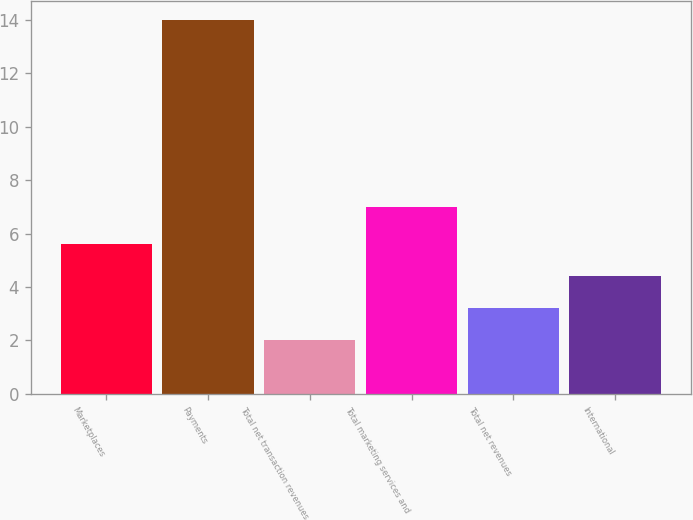<chart> <loc_0><loc_0><loc_500><loc_500><bar_chart><fcel>Marketplaces<fcel>Payments<fcel>Total net transaction revenues<fcel>Total marketing services and<fcel>Total net revenues<fcel>International<nl><fcel>5.6<fcel>14<fcel>2<fcel>7<fcel>3.2<fcel>4.4<nl></chart> 